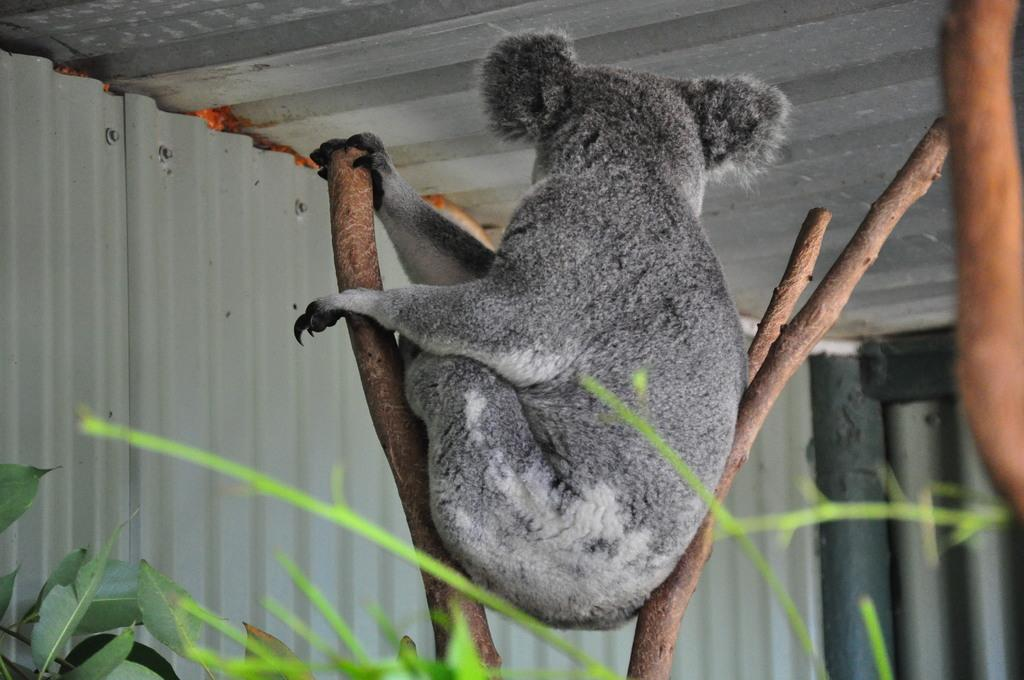What type of animal is in the image? There is an animal in the image, but its specific type cannot be determined from the provided facts. How is the animal positioned in the image? The animal is between sticks in the image. What color is the animal in the image? The animal is gray in color. What can be seen in the background of the image? There are plants and a shed in the background of the image. What color are the plants in the image? The plants are green in color. What color is the shed in the image? The shed is gray in color. What route does the animal take to reach the hook in the image? There is no hook present in the image, so the animal cannot take a route to reach it. 